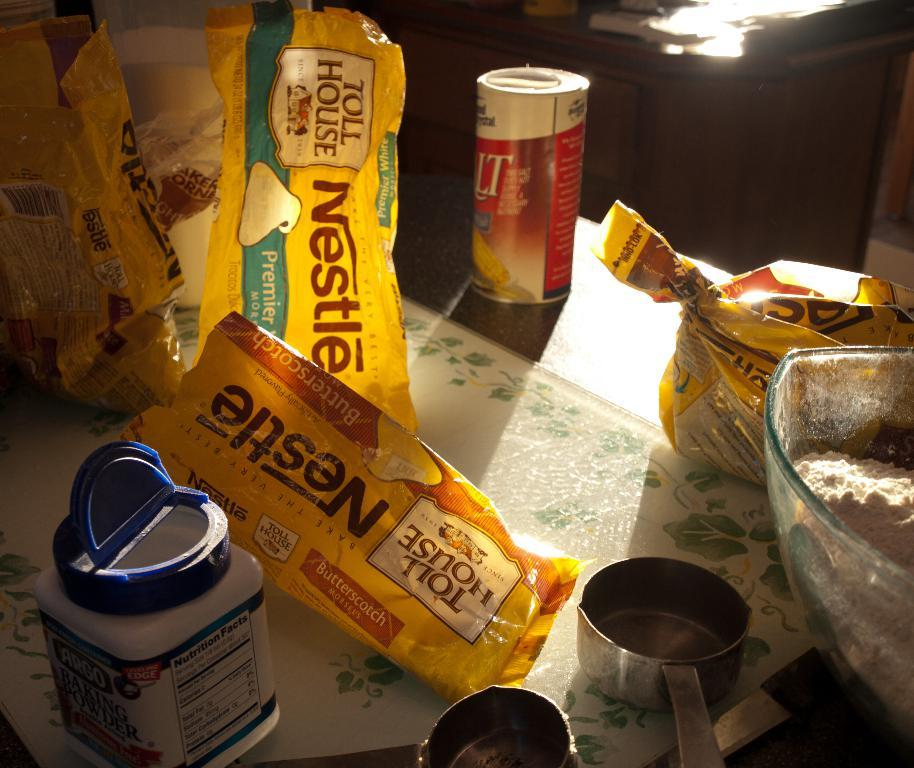<image>
Give a short and clear explanation of the subsequent image. someone's packaging who loves Nestle Tollhouse morsels. 